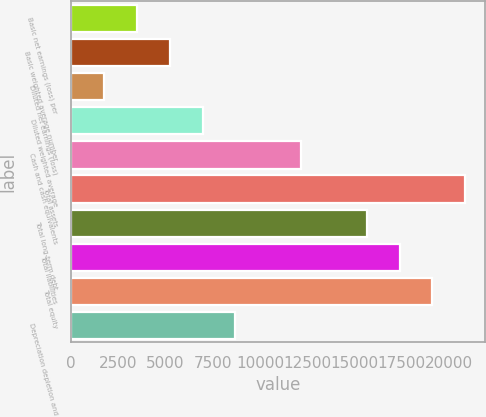Convert chart to OTSL. <chart><loc_0><loc_0><loc_500><loc_500><bar_chart><fcel>Basic net earnings (loss) per<fcel>Basic weighted average number<fcel>Diluted net earnings (loss)<fcel>Diluted weighted average<fcel>Cash and cash equivalents<fcel>Total assets<fcel>Total long-term debt<fcel>Total liabilities<fcel>Total equity<fcel>Depreciation depletion and<nl><fcel>3478.75<fcel>5217.59<fcel>1739.91<fcel>6956.43<fcel>12173<fcel>20867.2<fcel>15650.6<fcel>17389.5<fcel>19128.3<fcel>8695.27<nl></chart> 